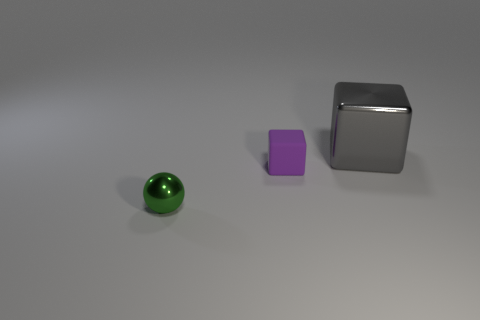Add 1 small red rubber cylinders. How many objects exist? 4 Subtract all spheres. How many objects are left? 2 Add 1 large gray metal blocks. How many large gray metal blocks are left? 2 Add 2 tiny blue shiny balls. How many tiny blue shiny balls exist? 2 Subtract 1 gray cubes. How many objects are left? 2 Subtract all tiny brown matte cubes. Subtract all tiny metal objects. How many objects are left? 2 